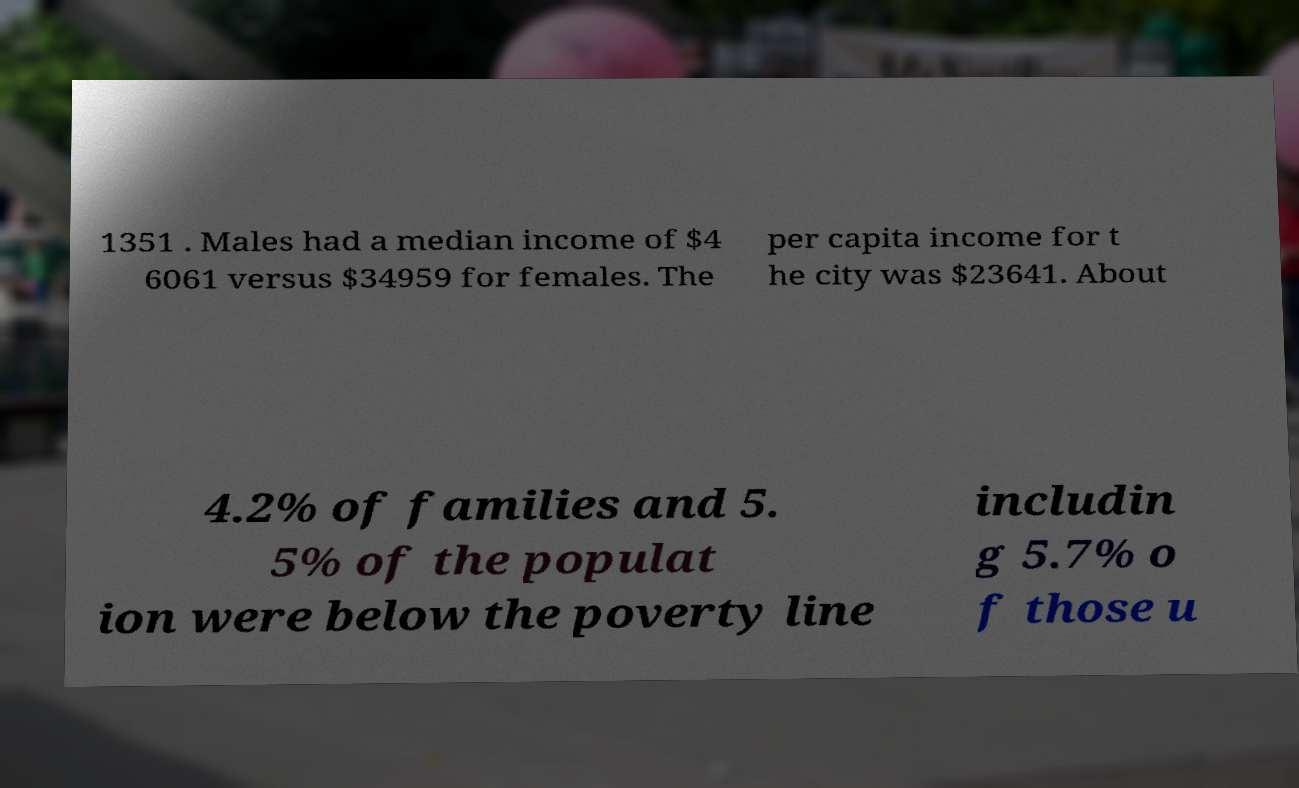What messages or text are displayed in this image? I need them in a readable, typed format. 1351 . Males had a median income of $4 6061 versus $34959 for females. The per capita income for t he city was $23641. About 4.2% of families and 5. 5% of the populat ion were below the poverty line includin g 5.7% o f those u 